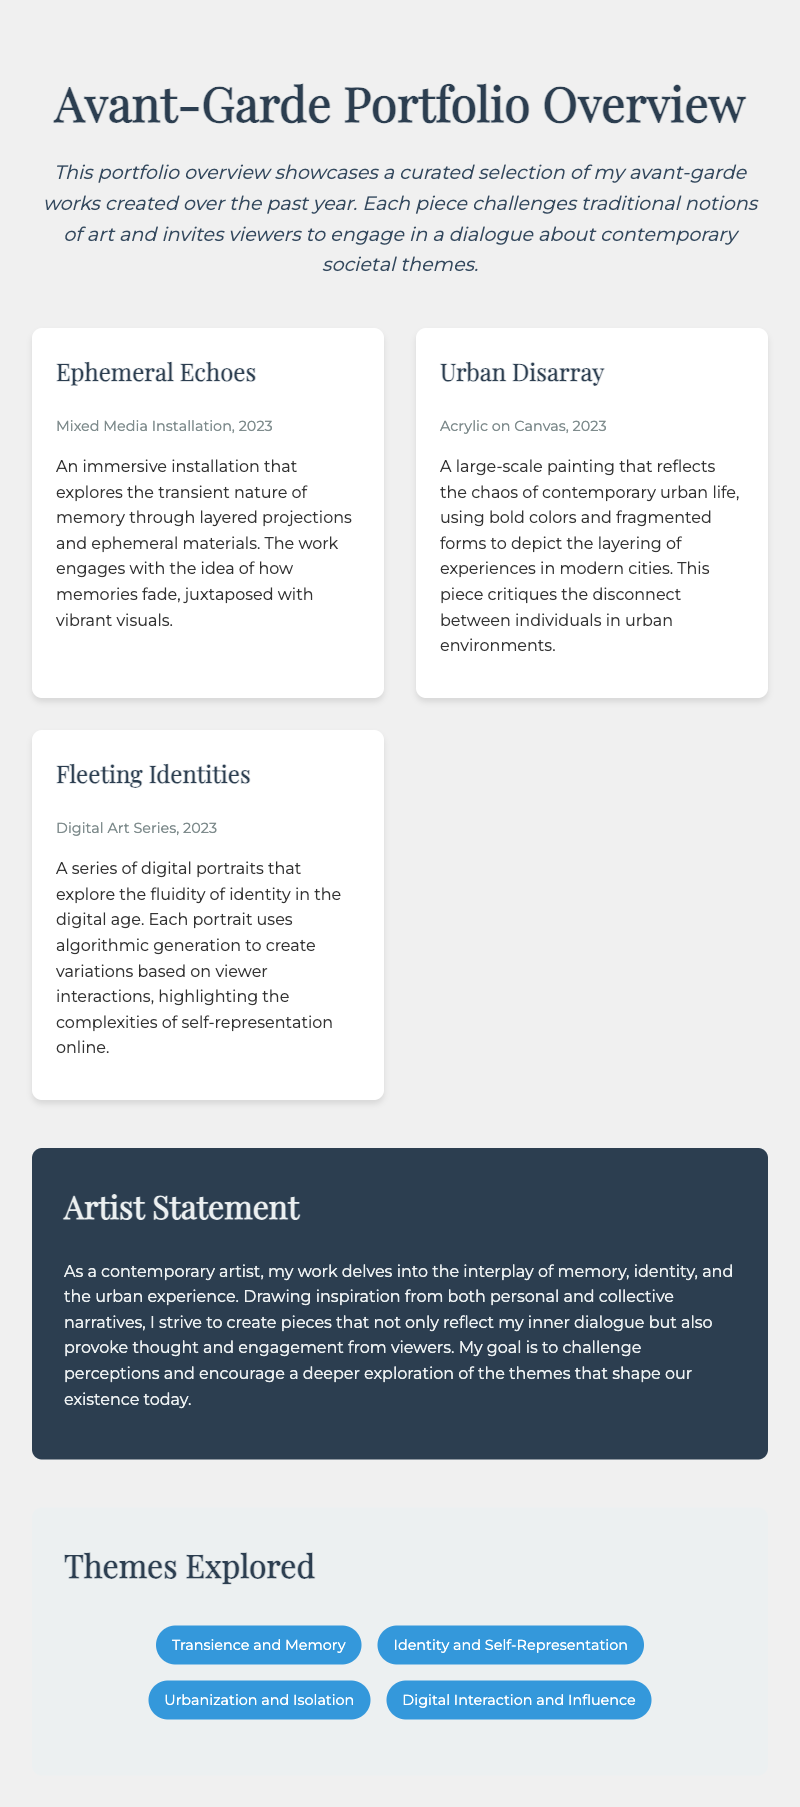What is the title of the portfolio overview? The title of the portfolio is stated at the top of the document, highlighting the theme of the artwork.
Answer: Avant-Garde Portfolio Overview Which work is a mixed media installation? This information is found in the description of the works, identifying the medium used for each piece.
Answer: Ephemeral Echoes What year was "Urban Disarray" created? The creation year is listed in the metadata of the artwork description.
Answer: 2023 How many themes are explored in the portfolio? The number of themes is determined by counting the list provided in the themes section of the document.
Answer: 4 What is the main focus of "Fleeting Identities"? The focus of each work is described, providing insight into the intent behind the artwork.
Answer: Fluidity of identity in the digital age Who wrote the artist statement? The artist statement's authorship is implied through the context of the document, referring to the creator of the works.
Answer: The artist What type of art is "Urban Disarray"? The medium of each artwork is specified in the document.
Answer: Acrylic on Canvas What aspect does the artist want to challenge? The artist's statement outlines the goals and intentions behind the artworks created.
Answer: Perceptions 